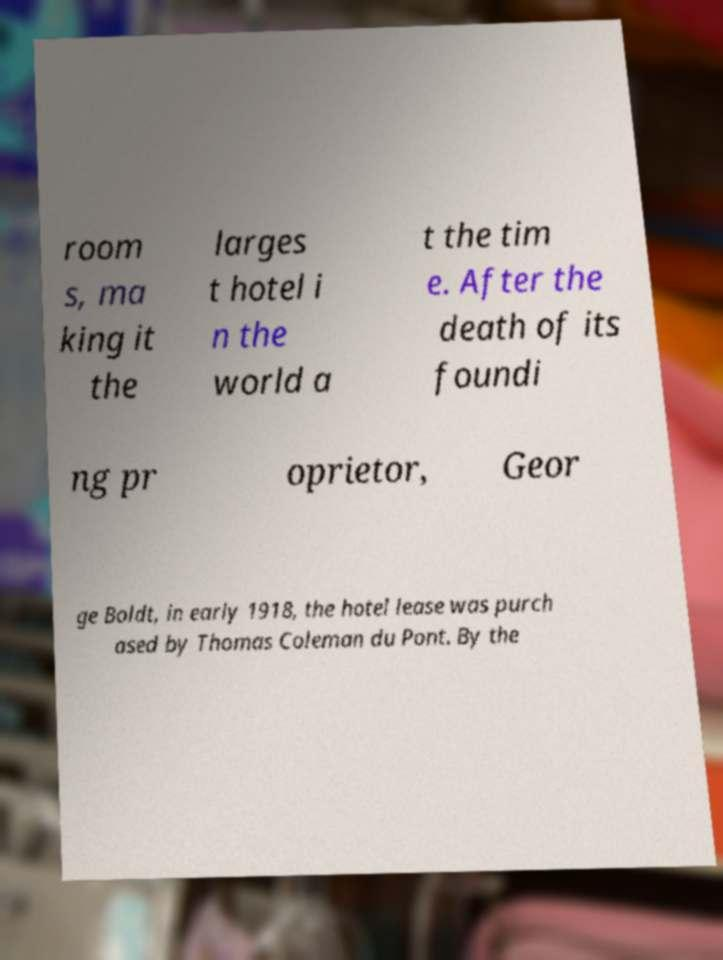What messages or text are displayed in this image? I need them in a readable, typed format. room s, ma king it the larges t hotel i n the world a t the tim e. After the death of its foundi ng pr oprietor, Geor ge Boldt, in early 1918, the hotel lease was purch ased by Thomas Coleman du Pont. By the 